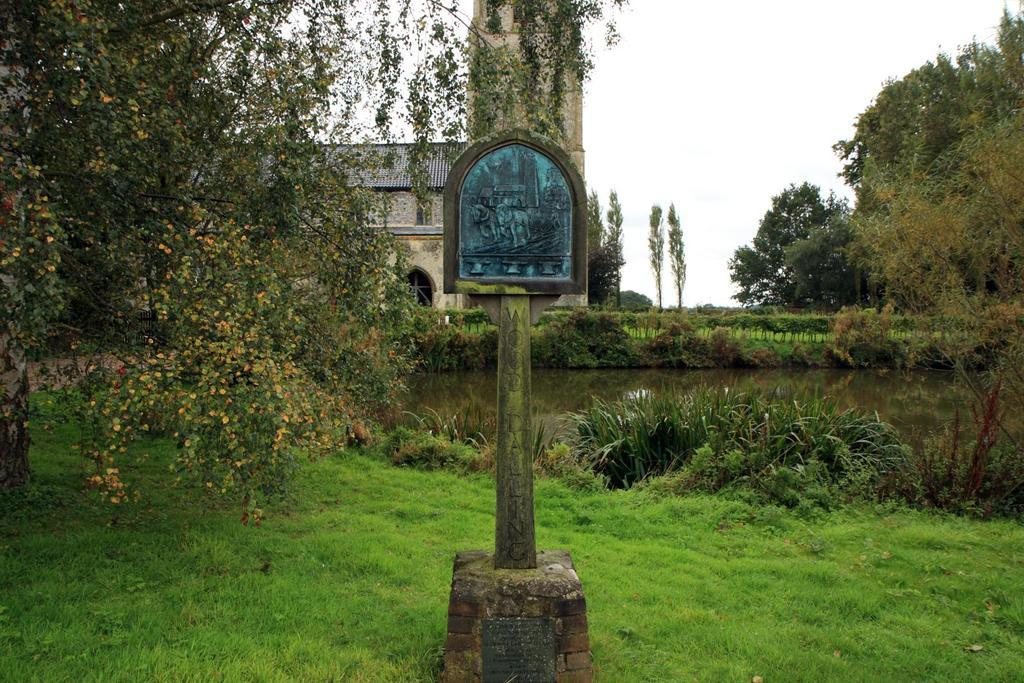What is on the pole in the image? There is a board on a pole in the image. What type of vegetation can be seen in the image? There is grass, plants, and trees present in the image. What natural element is visible in the image? Water is visible in the image. What type of structure is present in the image? There is a building in the image. What is visible in the background of the image? The sky is visible in the background of the image. How many daughters are playing with the fowl in the image? There are no daughters or fowl present in the image. What type of bridge can be seen connecting the trees in the image? There is no bridge present in the image; it features a board on a pole, grass, plants, trees, water, a building, and the sky. 